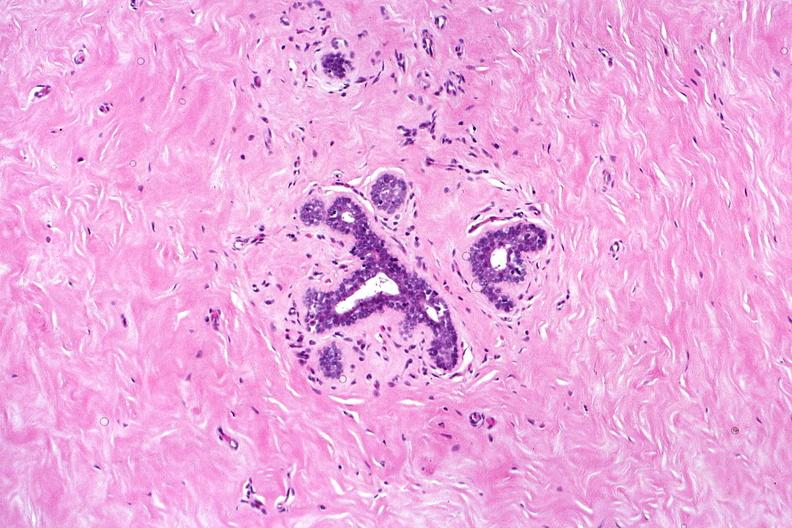what is present?
Answer the question using a single word or phrase. Female reproductive 